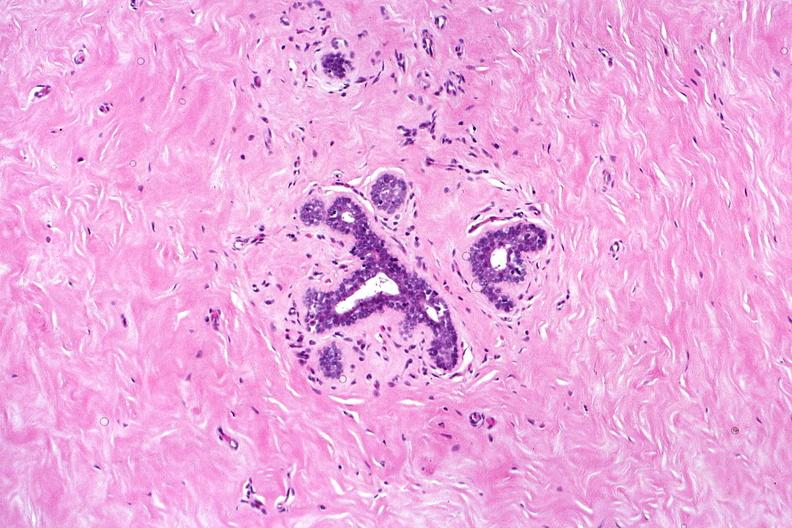what is present?
Answer the question using a single word or phrase. Female reproductive 